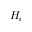<formula> <loc_0><loc_0><loc_500><loc_500>H _ { c }</formula> 